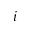Convert formula to latex. <formula><loc_0><loc_0><loc_500><loc_500>i</formula> 